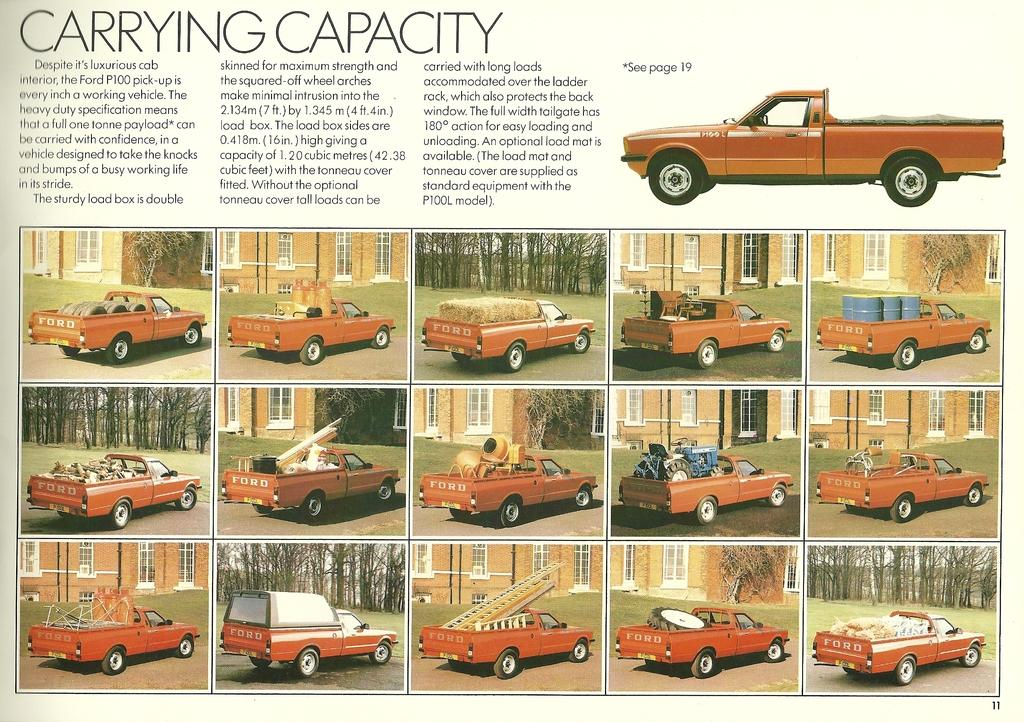What can be seen at the top of the paper in the image? There are texts written at the top of the paper. What is the main image on the paper? There is a vehicle picture on the paper. What type of shapes are present on the paper? There are square boxes on the paper. What is inside the square boxes on the paper? There are pictures of vehicles in the square boxes. How many children are visible on the page in the image? There are no children present on the page in the image. What type of shock can be seen affecting the vehicles in the square boxes? There is no shock present in the image; it only shows pictures of vehicles in square boxes. 